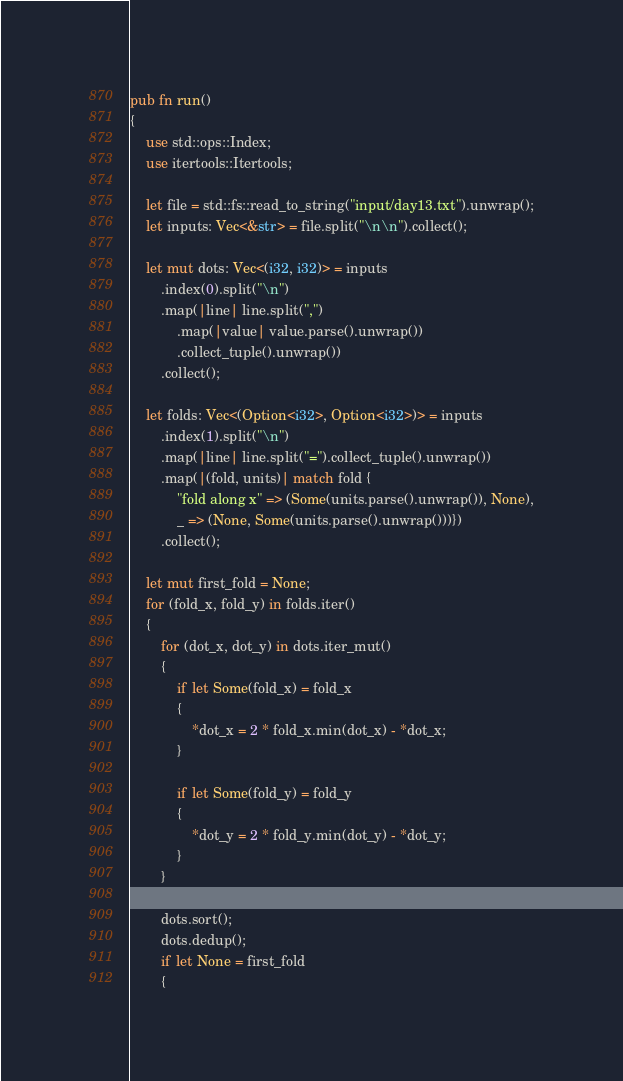<code> <loc_0><loc_0><loc_500><loc_500><_Rust_>
pub fn run()
{
    use std::ops::Index;
    use itertools::Itertools;

    let file = std::fs::read_to_string("input/day13.txt").unwrap();
    let inputs: Vec<&str> = file.split("\n\n").collect();

    let mut dots: Vec<(i32, i32)> = inputs
        .index(0).split("\n")
        .map(|line| line.split(",")
            .map(|value| value.parse().unwrap())
            .collect_tuple().unwrap())
        .collect();

    let folds: Vec<(Option<i32>, Option<i32>)> = inputs
        .index(1).split("\n")
        .map(|line| line.split("=").collect_tuple().unwrap())
        .map(|(fold, units)| match fold {
            "fold along x" => (Some(units.parse().unwrap()), None),
            _ => (None, Some(units.parse().unwrap()))})
        .collect();

    let mut first_fold = None;
    for (fold_x, fold_y) in folds.iter()
    {
        for (dot_x, dot_y) in dots.iter_mut()
        {
            if let Some(fold_x) = fold_x
            {
                *dot_x = 2 * fold_x.min(dot_x) - *dot_x;
            }
            
            if let Some(fold_y) = fold_y
            {
                *dot_y = 2 * fold_y.min(dot_y) - *dot_y;
            }
        }

        dots.sort();
        dots.dedup();
        if let None = first_fold
        {</code> 